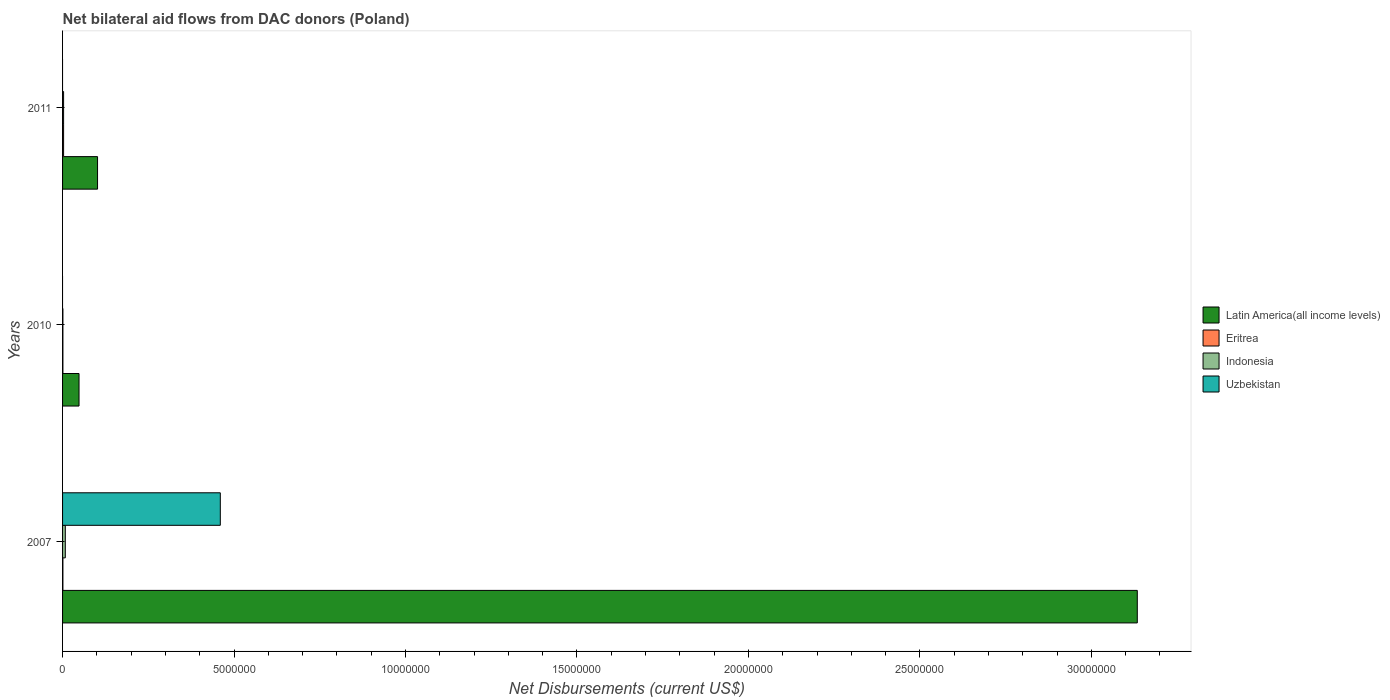How many groups of bars are there?
Your response must be concise. 3. Are the number of bars per tick equal to the number of legend labels?
Your answer should be compact. No. Are the number of bars on each tick of the Y-axis equal?
Your response must be concise. No. How many bars are there on the 3rd tick from the top?
Your answer should be very brief. 4. How many bars are there on the 1st tick from the bottom?
Offer a terse response. 4. What is the label of the 3rd group of bars from the top?
Provide a succinct answer. 2007. In how many cases, is the number of bars for a given year not equal to the number of legend labels?
Your answer should be very brief. 2. What is the net bilateral aid flows in Latin America(all income levels) in 2007?
Your response must be concise. 3.13e+07. Across all years, what is the maximum net bilateral aid flows in Indonesia?
Your response must be concise. 8.00e+04. In which year was the net bilateral aid flows in Latin America(all income levels) maximum?
Your answer should be compact. 2007. What is the total net bilateral aid flows in Uzbekistan in the graph?
Keep it short and to the point. 4.60e+06. What is the difference between the net bilateral aid flows in Indonesia in 2007 and that in 2011?
Your response must be concise. 5.00e+04. What is the average net bilateral aid flows in Eritrea per year?
Your answer should be very brief. 1.67e+04. In the year 2007, what is the difference between the net bilateral aid flows in Eritrea and net bilateral aid flows in Latin America(all income levels)?
Your answer should be compact. -3.13e+07. In how many years, is the net bilateral aid flows in Latin America(all income levels) greater than 30000000 US$?
Provide a succinct answer. 1. What is the ratio of the net bilateral aid flows in Indonesia in 2010 to that in 2011?
Provide a succinct answer. 0.33. What is the difference between the highest and the lowest net bilateral aid flows in Latin America(all income levels)?
Offer a very short reply. 3.09e+07. In how many years, is the net bilateral aid flows in Eritrea greater than the average net bilateral aid flows in Eritrea taken over all years?
Offer a terse response. 1. Is the sum of the net bilateral aid flows in Latin America(all income levels) in 2007 and 2010 greater than the maximum net bilateral aid flows in Indonesia across all years?
Give a very brief answer. Yes. Is it the case that in every year, the sum of the net bilateral aid flows in Uzbekistan and net bilateral aid flows in Latin America(all income levels) is greater than the sum of net bilateral aid flows in Eritrea and net bilateral aid flows in Indonesia?
Your answer should be compact. No. Is it the case that in every year, the sum of the net bilateral aid flows in Eritrea and net bilateral aid flows in Indonesia is greater than the net bilateral aid flows in Uzbekistan?
Keep it short and to the point. No. Are all the bars in the graph horizontal?
Make the answer very short. Yes. How many years are there in the graph?
Provide a succinct answer. 3. Does the graph contain any zero values?
Provide a succinct answer. Yes. Does the graph contain grids?
Give a very brief answer. No. Where does the legend appear in the graph?
Your answer should be very brief. Center right. How are the legend labels stacked?
Offer a very short reply. Vertical. What is the title of the graph?
Keep it short and to the point. Net bilateral aid flows from DAC donors (Poland). What is the label or title of the X-axis?
Your response must be concise. Net Disbursements (current US$). What is the Net Disbursements (current US$) in Latin America(all income levels) in 2007?
Your response must be concise. 3.13e+07. What is the Net Disbursements (current US$) of Uzbekistan in 2007?
Offer a terse response. 4.60e+06. What is the Net Disbursements (current US$) of Uzbekistan in 2010?
Keep it short and to the point. 0. What is the Net Disbursements (current US$) in Latin America(all income levels) in 2011?
Provide a succinct answer. 1.02e+06. What is the Net Disbursements (current US$) in Eritrea in 2011?
Your answer should be very brief. 3.00e+04. What is the Net Disbursements (current US$) of Indonesia in 2011?
Ensure brevity in your answer.  3.00e+04. Across all years, what is the maximum Net Disbursements (current US$) in Latin America(all income levels)?
Make the answer very short. 3.13e+07. Across all years, what is the maximum Net Disbursements (current US$) in Eritrea?
Provide a succinct answer. 3.00e+04. Across all years, what is the maximum Net Disbursements (current US$) in Indonesia?
Offer a terse response. 8.00e+04. Across all years, what is the maximum Net Disbursements (current US$) of Uzbekistan?
Offer a terse response. 4.60e+06. Across all years, what is the minimum Net Disbursements (current US$) in Latin America(all income levels)?
Provide a short and direct response. 4.80e+05. Across all years, what is the minimum Net Disbursements (current US$) in Uzbekistan?
Your answer should be very brief. 0. What is the total Net Disbursements (current US$) in Latin America(all income levels) in the graph?
Offer a very short reply. 3.28e+07. What is the total Net Disbursements (current US$) of Indonesia in the graph?
Your answer should be compact. 1.20e+05. What is the total Net Disbursements (current US$) in Uzbekistan in the graph?
Your answer should be compact. 4.60e+06. What is the difference between the Net Disbursements (current US$) in Latin America(all income levels) in 2007 and that in 2010?
Your answer should be very brief. 3.09e+07. What is the difference between the Net Disbursements (current US$) in Latin America(all income levels) in 2007 and that in 2011?
Offer a very short reply. 3.03e+07. What is the difference between the Net Disbursements (current US$) in Latin America(all income levels) in 2010 and that in 2011?
Provide a short and direct response. -5.40e+05. What is the difference between the Net Disbursements (current US$) of Latin America(all income levels) in 2007 and the Net Disbursements (current US$) of Eritrea in 2010?
Your answer should be very brief. 3.13e+07. What is the difference between the Net Disbursements (current US$) in Latin America(all income levels) in 2007 and the Net Disbursements (current US$) in Indonesia in 2010?
Keep it short and to the point. 3.13e+07. What is the difference between the Net Disbursements (current US$) in Eritrea in 2007 and the Net Disbursements (current US$) in Indonesia in 2010?
Provide a succinct answer. 0. What is the difference between the Net Disbursements (current US$) in Latin America(all income levels) in 2007 and the Net Disbursements (current US$) in Eritrea in 2011?
Offer a terse response. 3.13e+07. What is the difference between the Net Disbursements (current US$) of Latin America(all income levels) in 2007 and the Net Disbursements (current US$) of Indonesia in 2011?
Make the answer very short. 3.13e+07. What is the difference between the Net Disbursements (current US$) of Eritrea in 2007 and the Net Disbursements (current US$) of Indonesia in 2011?
Give a very brief answer. -2.00e+04. What is the difference between the Net Disbursements (current US$) of Eritrea in 2010 and the Net Disbursements (current US$) of Indonesia in 2011?
Your response must be concise. -2.00e+04. What is the average Net Disbursements (current US$) of Latin America(all income levels) per year?
Ensure brevity in your answer.  1.09e+07. What is the average Net Disbursements (current US$) of Eritrea per year?
Your answer should be very brief. 1.67e+04. What is the average Net Disbursements (current US$) of Indonesia per year?
Make the answer very short. 4.00e+04. What is the average Net Disbursements (current US$) of Uzbekistan per year?
Provide a short and direct response. 1.53e+06. In the year 2007, what is the difference between the Net Disbursements (current US$) in Latin America(all income levels) and Net Disbursements (current US$) in Eritrea?
Keep it short and to the point. 3.13e+07. In the year 2007, what is the difference between the Net Disbursements (current US$) in Latin America(all income levels) and Net Disbursements (current US$) in Indonesia?
Your response must be concise. 3.13e+07. In the year 2007, what is the difference between the Net Disbursements (current US$) in Latin America(all income levels) and Net Disbursements (current US$) in Uzbekistan?
Provide a short and direct response. 2.67e+07. In the year 2007, what is the difference between the Net Disbursements (current US$) in Eritrea and Net Disbursements (current US$) in Indonesia?
Keep it short and to the point. -7.00e+04. In the year 2007, what is the difference between the Net Disbursements (current US$) in Eritrea and Net Disbursements (current US$) in Uzbekistan?
Offer a very short reply. -4.59e+06. In the year 2007, what is the difference between the Net Disbursements (current US$) of Indonesia and Net Disbursements (current US$) of Uzbekistan?
Your answer should be very brief. -4.52e+06. In the year 2010, what is the difference between the Net Disbursements (current US$) in Latin America(all income levels) and Net Disbursements (current US$) in Eritrea?
Offer a very short reply. 4.70e+05. In the year 2011, what is the difference between the Net Disbursements (current US$) of Latin America(all income levels) and Net Disbursements (current US$) of Eritrea?
Your response must be concise. 9.90e+05. In the year 2011, what is the difference between the Net Disbursements (current US$) of Latin America(all income levels) and Net Disbursements (current US$) of Indonesia?
Make the answer very short. 9.90e+05. In the year 2011, what is the difference between the Net Disbursements (current US$) in Eritrea and Net Disbursements (current US$) in Indonesia?
Your answer should be compact. 0. What is the ratio of the Net Disbursements (current US$) in Latin America(all income levels) in 2007 to that in 2010?
Provide a short and direct response. 65.29. What is the ratio of the Net Disbursements (current US$) of Indonesia in 2007 to that in 2010?
Keep it short and to the point. 8. What is the ratio of the Net Disbursements (current US$) in Latin America(all income levels) in 2007 to that in 2011?
Your answer should be very brief. 30.73. What is the ratio of the Net Disbursements (current US$) in Eritrea in 2007 to that in 2011?
Offer a very short reply. 0.33. What is the ratio of the Net Disbursements (current US$) in Indonesia in 2007 to that in 2011?
Your response must be concise. 2.67. What is the ratio of the Net Disbursements (current US$) of Latin America(all income levels) in 2010 to that in 2011?
Your answer should be very brief. 0.47. What is the ratio of the Net Disbursements (current US$) of Eritrea in 2010 to that in 2011?
Make the answer very short. 0.33. What is the difference between the highest and the second highest Net Disbursements (current US$) of Latin America(all income levels)?
Keep it short and to the point. 3.03e+07. What is the difference between the highest and the lowest Net Disbursements (current US$) in Latin America(all income levels)?
Your answer should be very brief. 3.09e+07. What is the difference between the highest and the lowest Net Disbursements (current US$) of Eritrea?
Offer a terse response. 2.00e+04. What is the difference between the highest and the lowest Net Disbursements (current US$) of Indonesia?
Make the answer very short. 7.00e+04. What is the difference between the highest and the lowest Net Disbursements (current US$) of Uzbekistan?
Offer a terse response. 4.60e+06. 